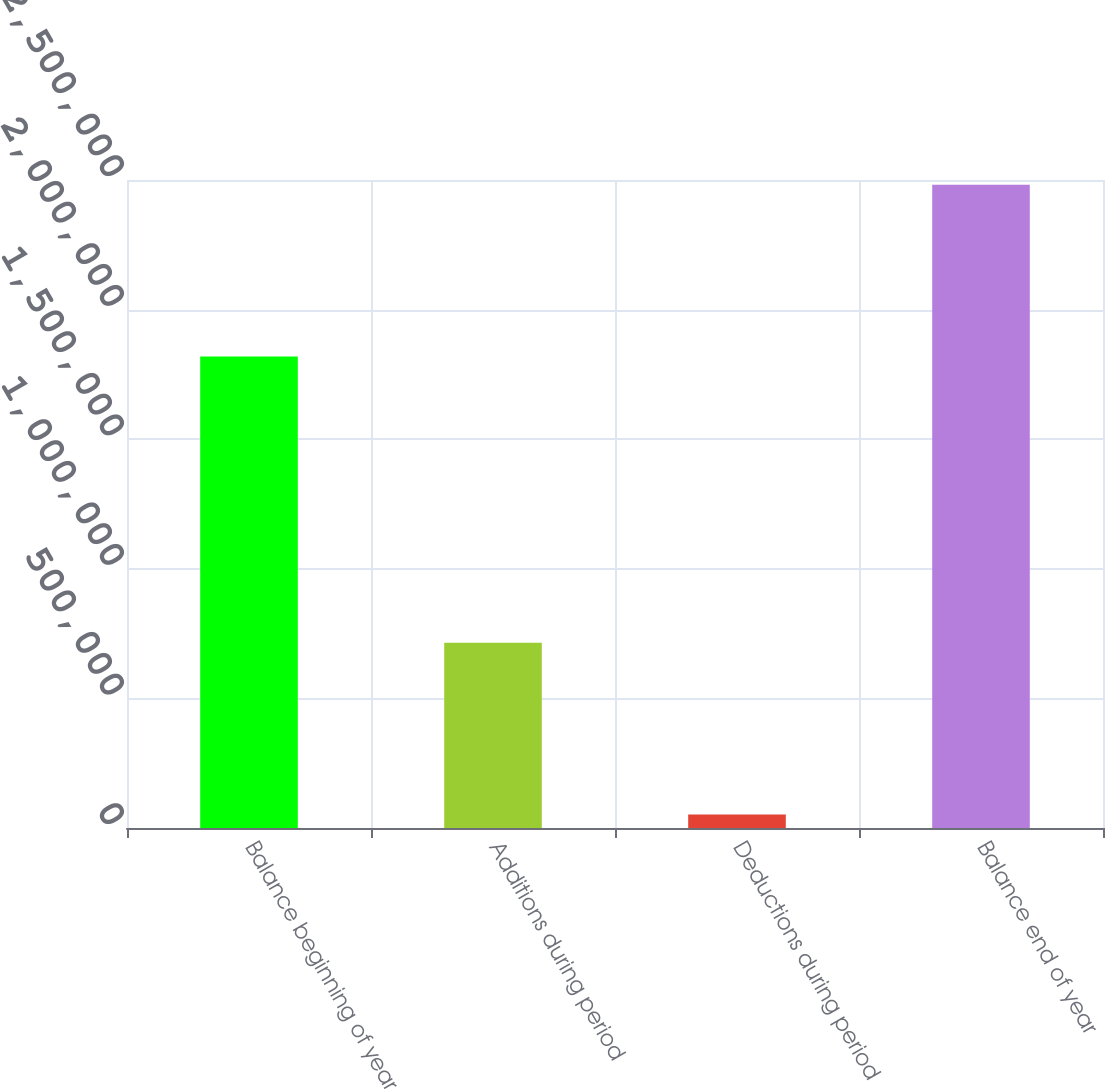<chart> <loc_0><loc_0><loc_500><loc_500><bar_chart><fcel>Balance beginning of year<fcel>Additions during period<fcel>Deductions during period<fcel>Balance end of year<nl><fcel>1.81933e+06<fcel>714335<fcel>52389<fcel>2.48127e+06<nl></chart> 